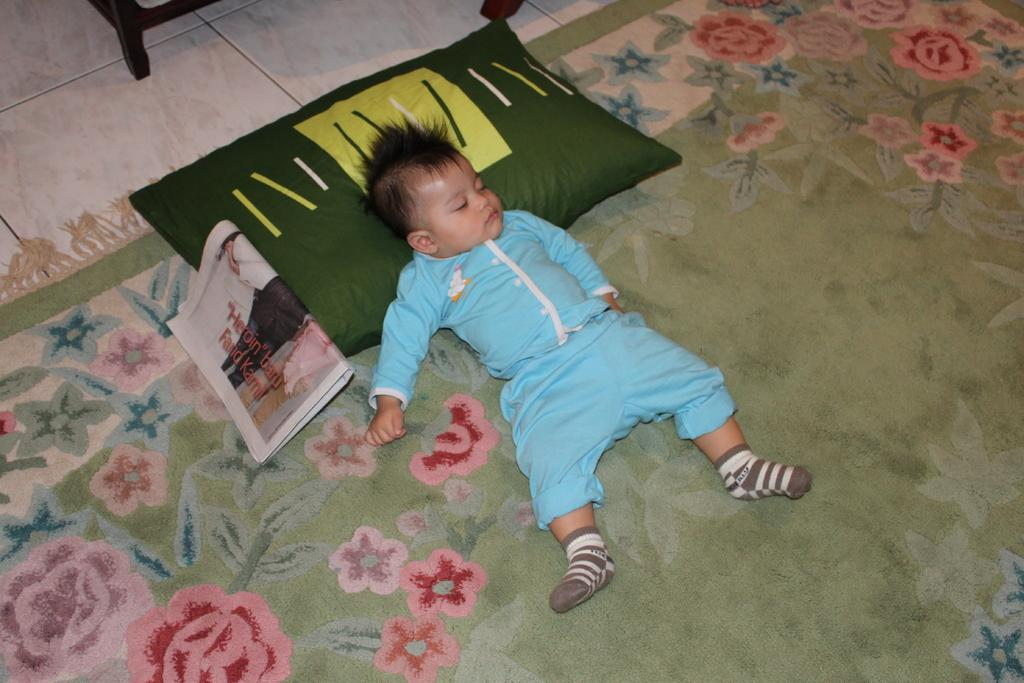What is the boy doing in the image? The boy is sleeping on the carpet. What is on the carpet besides the boy? There is a pillow and a newspaper on the carpet. What can be seen at the top of the image? The floor is visible at the top of the image, and there is a wooden object there as well. How does the boy feel about the turkey in the image? There is no turkey present in the image, so it is not possible to determine how the boy feels about it. 